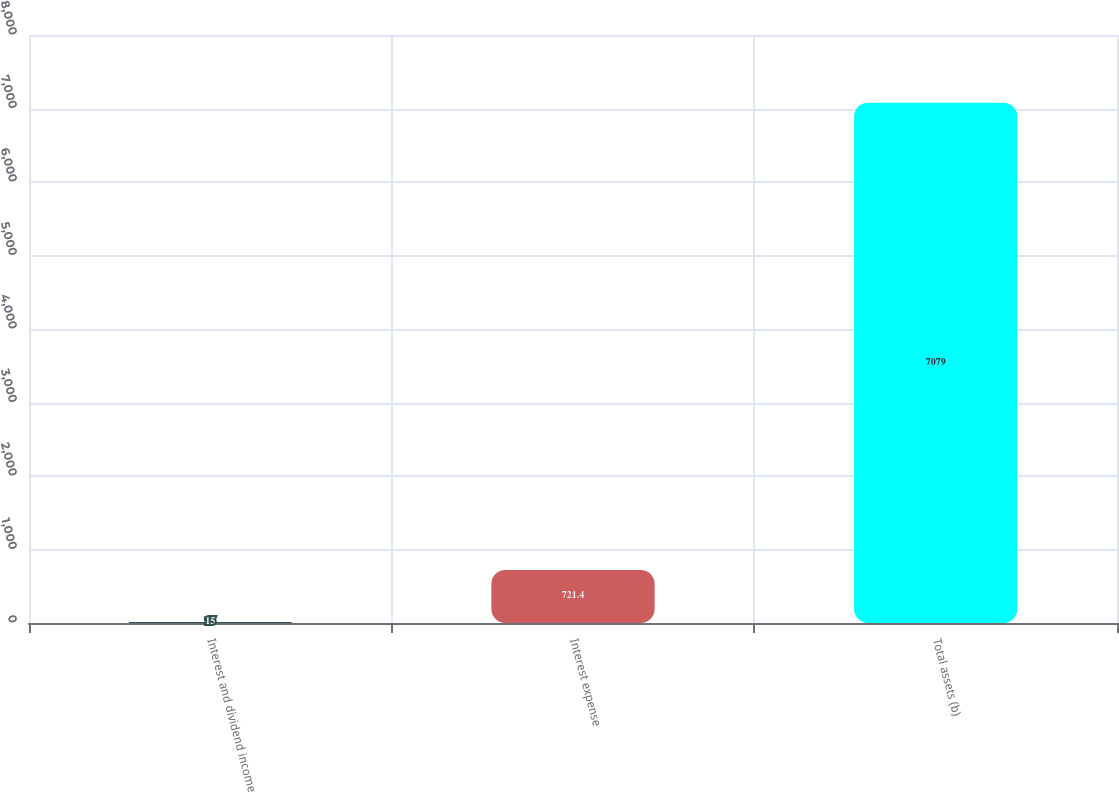<chart> <loc_0><loc_0><loc_500><loc_500><bar_chart><fcel>Interest and dividend income<fcel>Interest expense<fcel>Total assets (b)<nl><fcel>15<fcel>721.4<fcel>7079<nl></chart> 